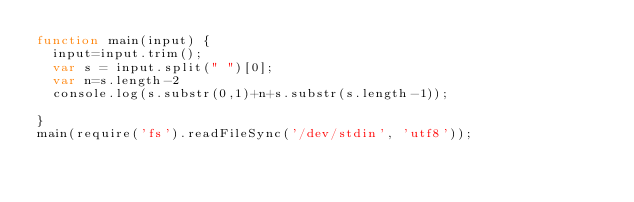Convert code to text. <code><loc_0><loc_0><loc_500><loc_500><_JavaScript_>function main(input) {
  input=input.trim();
  var s = input.split(" ")[0];
  var n=s.length-2
  console.log(s.substr(0,1)+n+s.substr(s.length-1));

}
main(require('fs').readFileSync('/dev/stdin', 'utf8'));</code> 